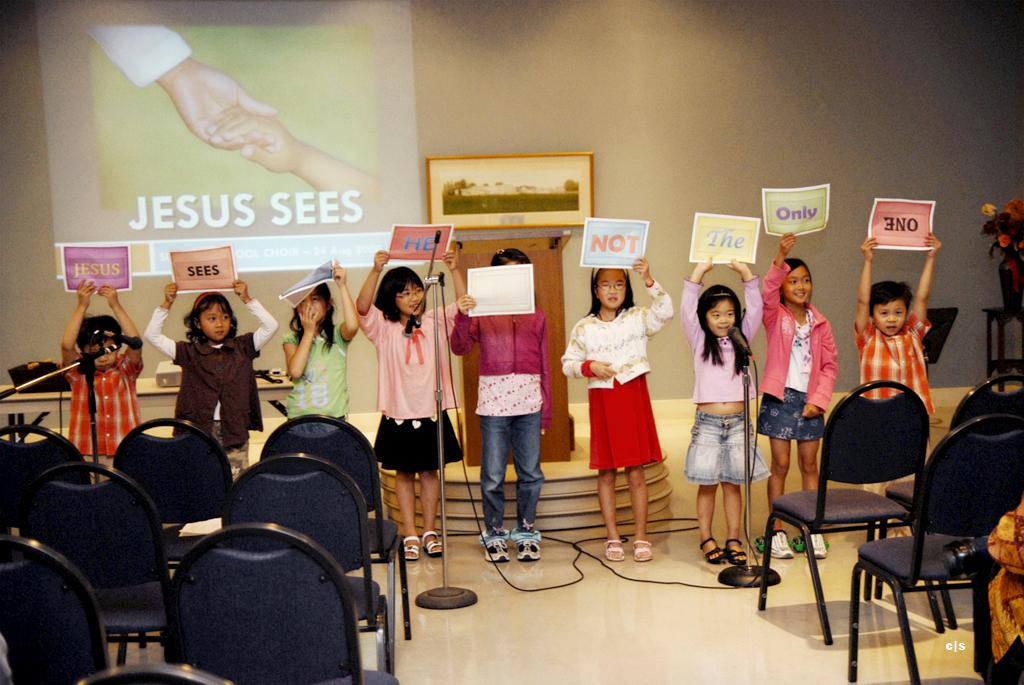What are the kids in the image doing? The kids are standing in the image and holding papers. What objects are present in the image that might be used for sitting? There are chairs in the image. What equipment is visible in the image that might be used for amplifying sound? There are microphones with stands in the image. What can be seen in the background of the image? There is a wall, a screen, a podium, and flowers in a vase in the background of the image. What type of transport can be seen in the image? There is no transport visible in the image. What role does the mother play in the image? There is no mention of a mother in the image, so it is not possible to determine her role. 